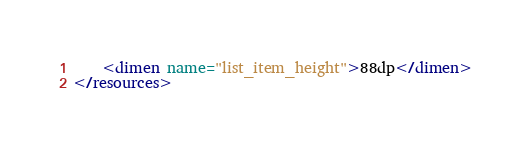<code> <loc_0><loc_0><loc_500><loc_500><_XML_>    <dimen name="list_item_height">88dp</dimen>
</resources>
</code> 